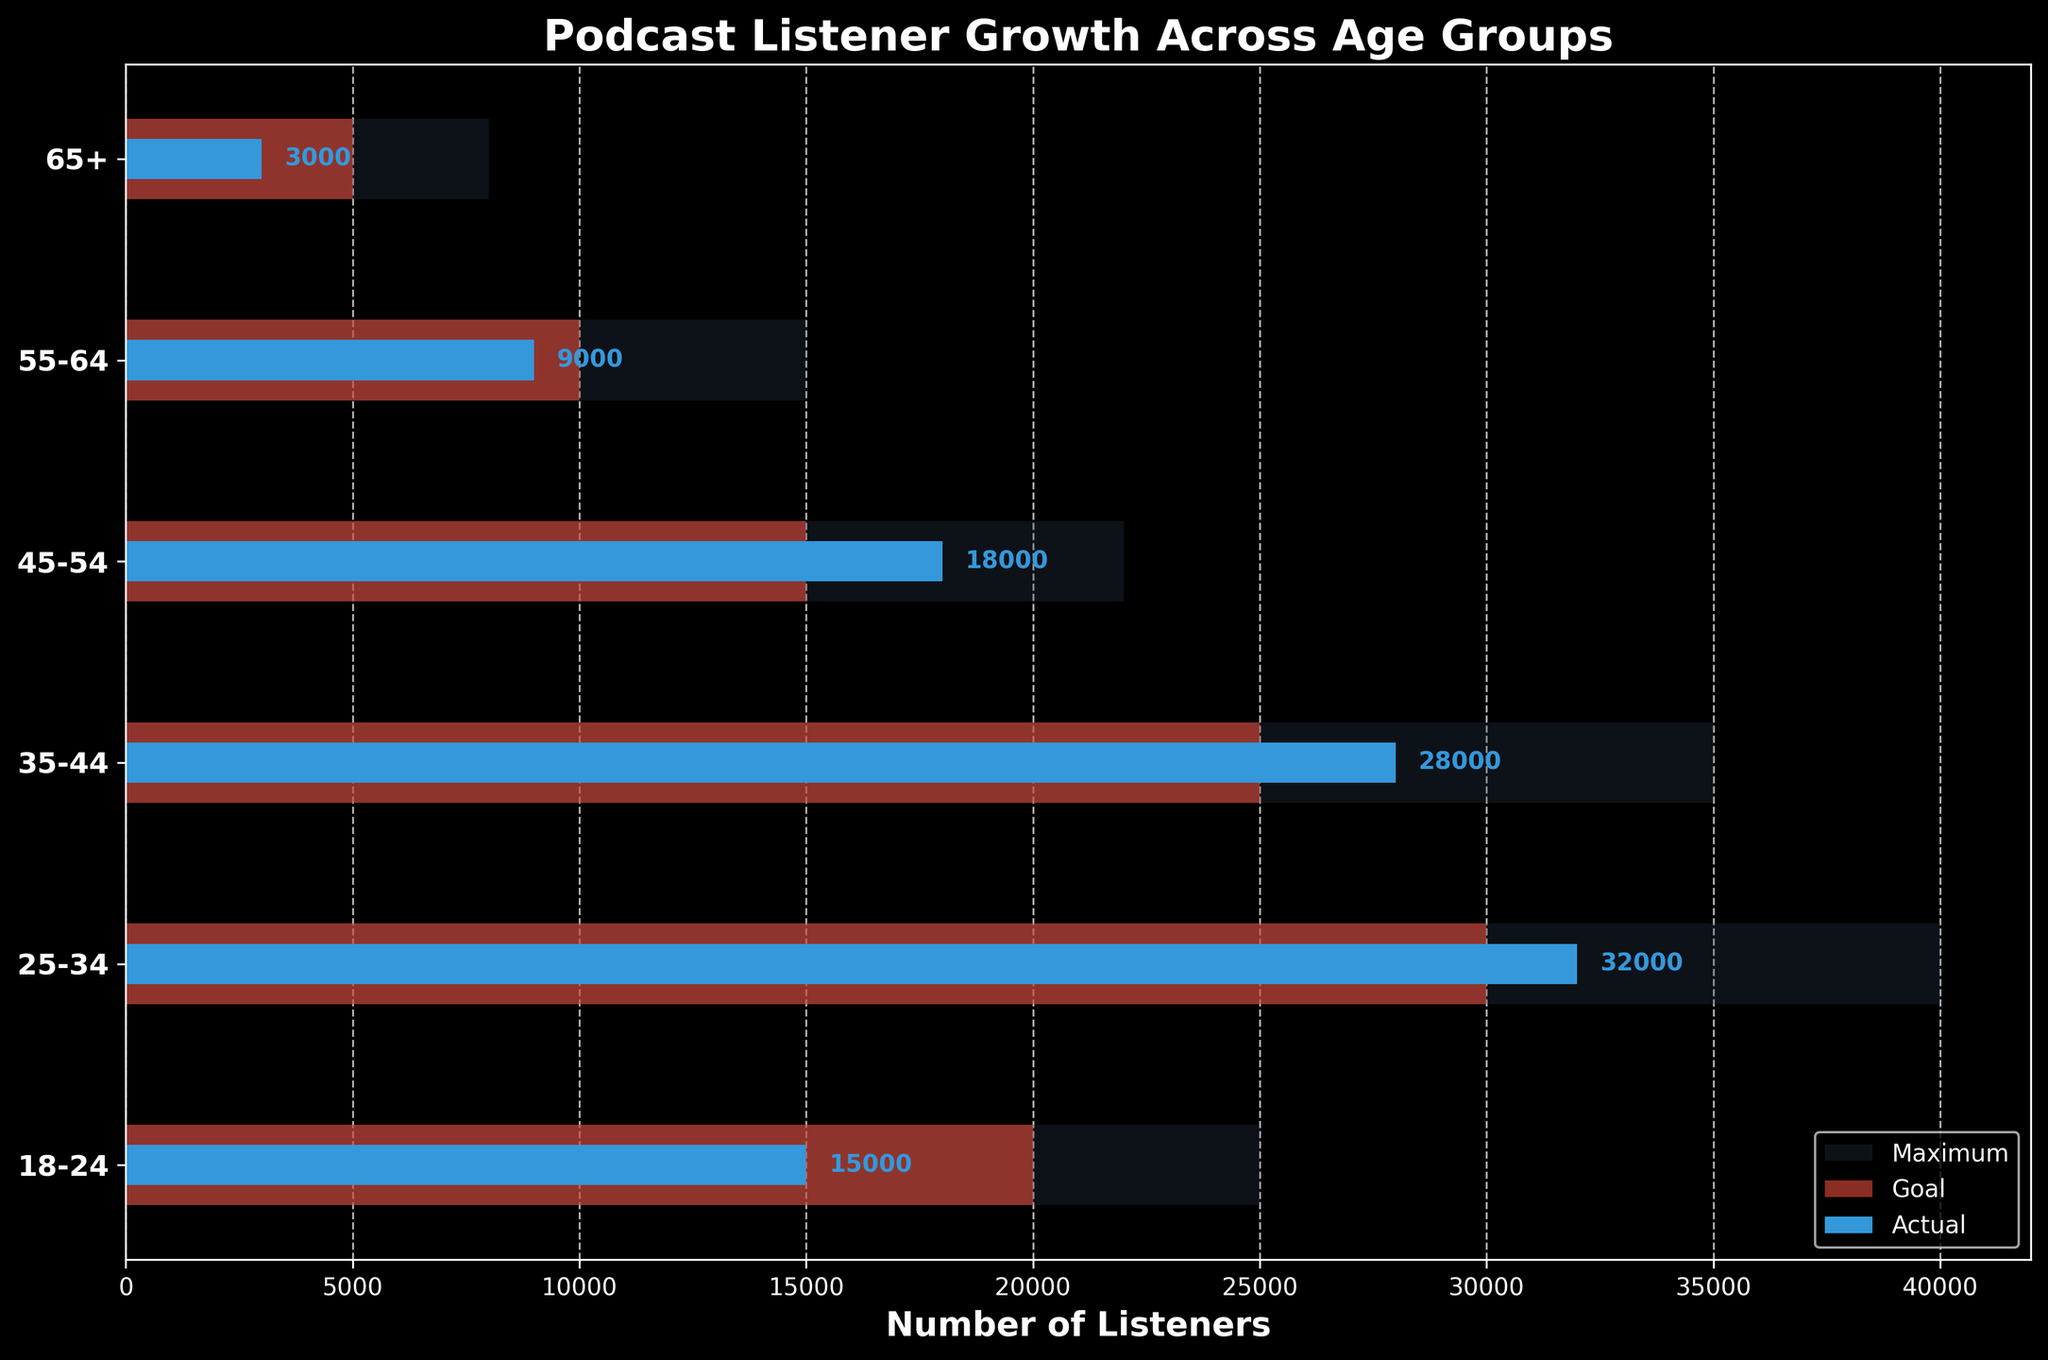How many age groups are displayed in the chart? The chart has y-ticks labeled with different age groups. Counting the labels gives us the total number of age groups.
Answer: 6 What is the title of the chart? The title is displayed at the top of the chart.
Answer: Podcast Listener Growth Across Age Groups What is the range of Maximum listeners for the 25-34 age group? The Maximum listeners bar for the 25-34 age group extends horizontally to around 40,000 on the x-axis.
Answer: 40,000 Which age group has exceeded its listener goal by the largest margin? To find this, subtract the Goal from the Actual Listeners for each age group. The age group with the largest positive difference is the one that exceeded its goal by the largest margin.
Answer: 35-44 What proportion of the Goal was met for the 65+ age group? Divide the Actual Listeners by the Goal for the 65+ age group: \( \frac{3000}{5000} \approx 0.6 \).
Answer: 60% How does the number of Actual Listeners in the 18-24 age group compare to the Goal for the same group? The Actual Listeners bar for the 18-24 age group extends to 15,000, while the Goal bar extends to 20,000. 15,000 is less than 20,000.
Answer: Less than Which age group has the closest number of Actual Listeners to its Goal? Find the absolute difference between Actual Listeners and Goal for each age group and identify the smallest difference.
Answer: 55-64 What is the total number of Actual Listeners across all age groups? Sum the Actual Listeners values for each age group: 15,000 + 32,000 + 28,000 + 18,000 + 9,000 + 3,000 = 105,000.
Answer: 105,000 Which age group has the lowest number of Actual Listeners? Compare the lengths of the Actual Listeners bars for all age groups to find the smallest one.
Answer: 65+ Between which age groups is the difference in Goal values the greatest? Compare the differences in the Goal values between the age groups to find the largest difference. The largest is between the 18-24 group (20,000) and the 25-34 group (30,000), a difference of 10,000.
Answer: 18-24 and 25-34 